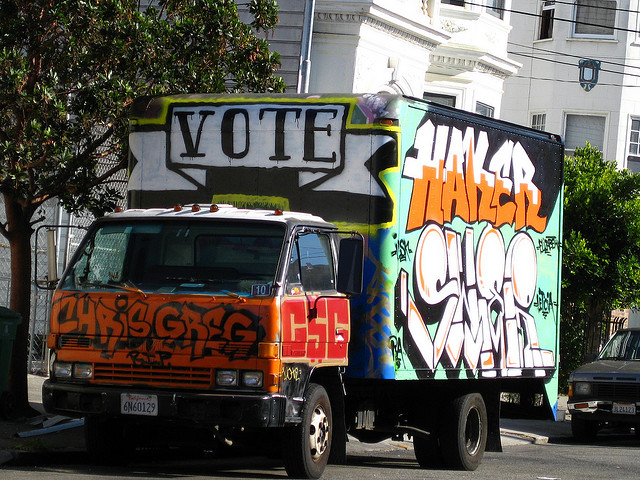Identify the text contained in this image. V O T E CHRIS G5G 6N60129 HAKER 